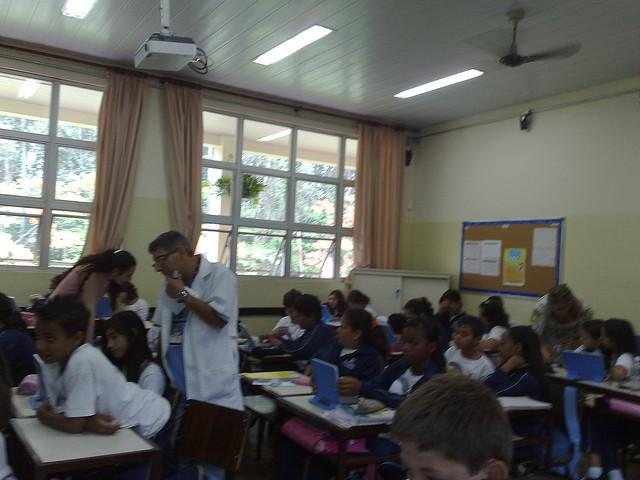What is the person in the white coat doing? teaching 